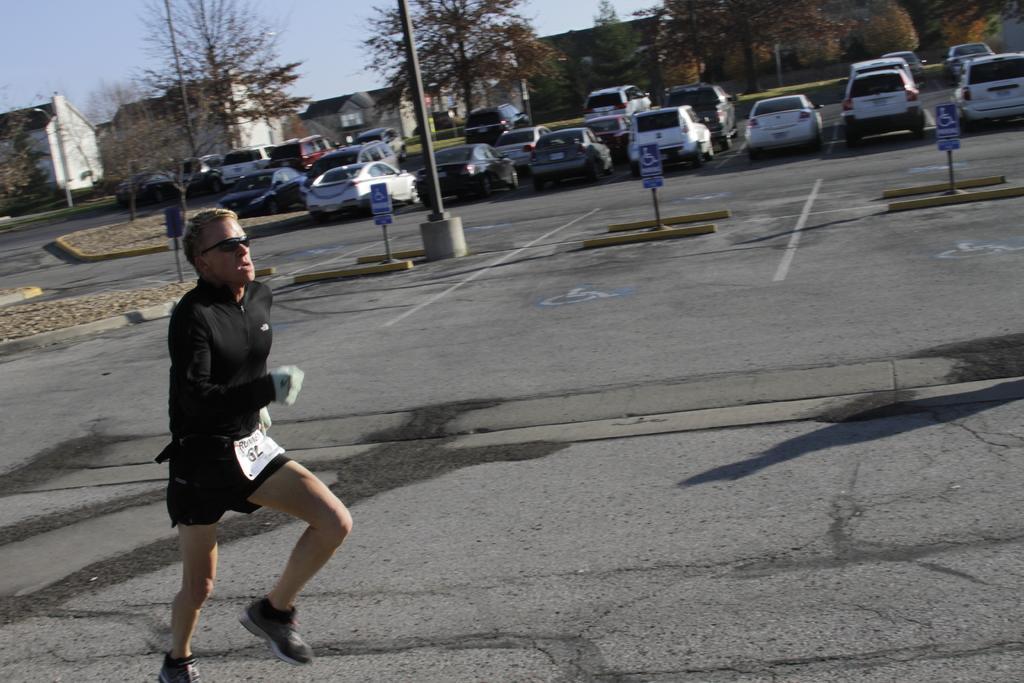Could you give a brief overview of what you see in this image? In the picture we can see a man running on the road wearing a black dress with shoes and in the background, we can see poles, cars are parked and trees and we can also see a house and sky. 